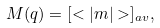Convert formula to latex. <formula><loc_0><loc_0><loc_500><loc_500>M ( q ) = [ < | m | > ] _ { a v } ,</formula> 